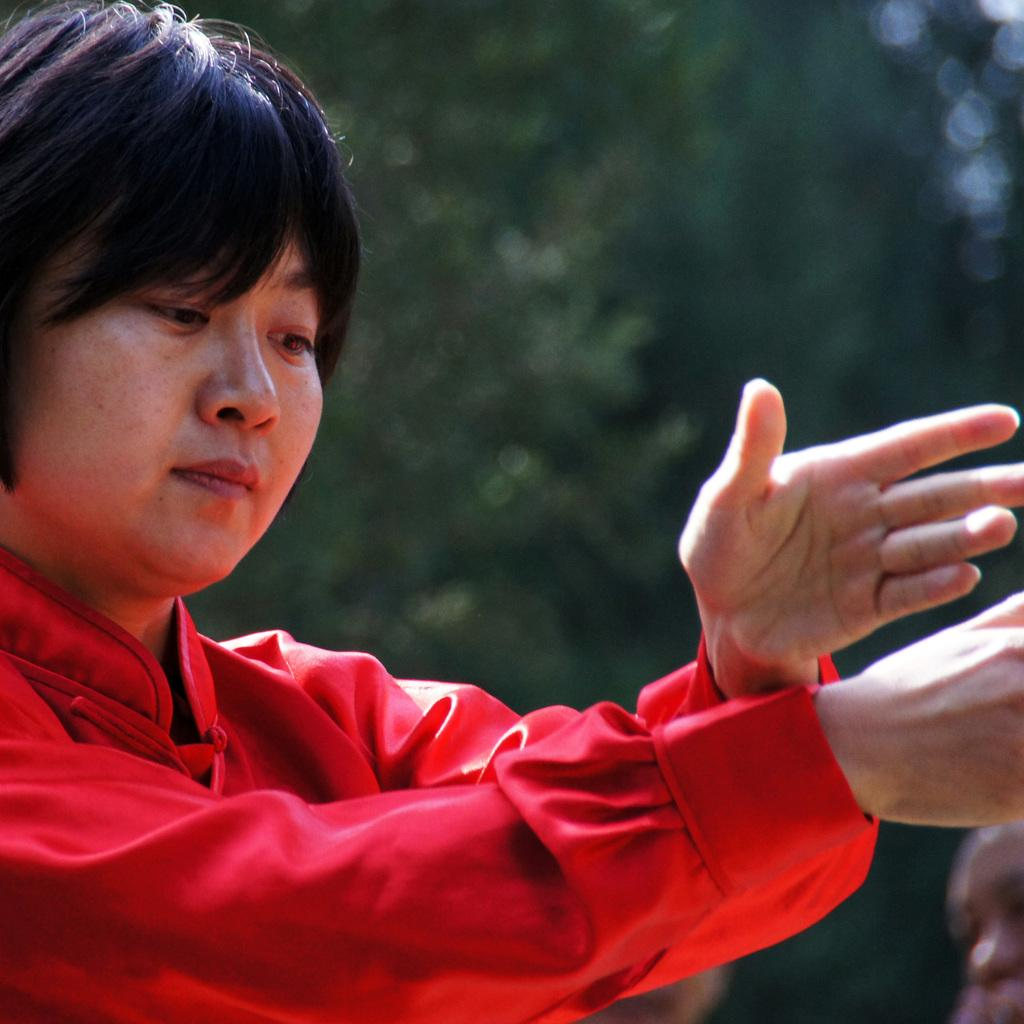What is the main subject of the image? There is a person in the image. What is the person wearing? The person is wearing a red dress. What color is the background of the image? The background of the image is green. What type of dog can be seen playing in the front of the image? There is no dog present in the image, and therefore no such activity can be observed. What type of soda is the person holding in the image? There is no soda visible in the image; the person is wearing a red dress and standing in front of a green background. 